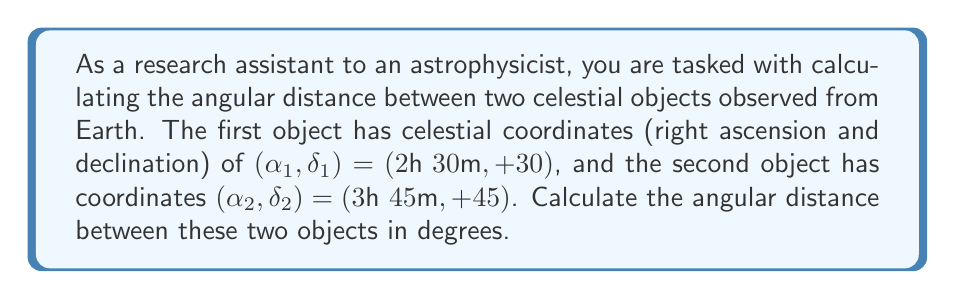Solve this math problem. To calculate the angular distance between two celestial objects, we can use the spherical law of cosines:

$$\cos(\theta) = \sin(\delta_1)\sin(\delta_2) + \cos(\delta_1)\cos(\delta_2)\cos(\Delta\alpha)$$

Where:
- $\theta$ is the angular distance
- $\delta_1$ and $\delta_2$ are the declinations of the two objects
- $\Delta\alpha$ is the difference in right ascension

Step 1: Convert all angles to degrees.
- $\delta_1 = 30°$
- $\delta_2 = 45°$
- $\alpha_1 = 2\text{h } 30\text{m} = 2.5\text{h} = 2.5 \times 15° = 37.5°$
- $\alpha_2 = 3\text{h } 45\text{m} = 3.75\text{h} = 3.75 \times 15° = 56.25°$
- $\Delta\alpha = 56.25° - 37.5° = 18.75°$

Step 2: Apply the spherical law of cosines:

$$\begin{align}
\cos(\theta) &= \sin(30°)\sin(45°) + \cos(30°)\cos(45°)\cos(18.75°) \\
&= (0.5)(0.7071) + (0.8660)(0.7071)(0.9467) \\
&= 0.3536 + 0.5796 \\
&= 0.9332
\end{align}$$

Step 3: Solve for $\theta$ by taking the inverse cosine (arccos):

$$\theta = \arccos(0.9332) = 21.02°$$

Therefore, the angular distance between the two celestial objects is approximately 21.02°.
Answer: 21.02° 